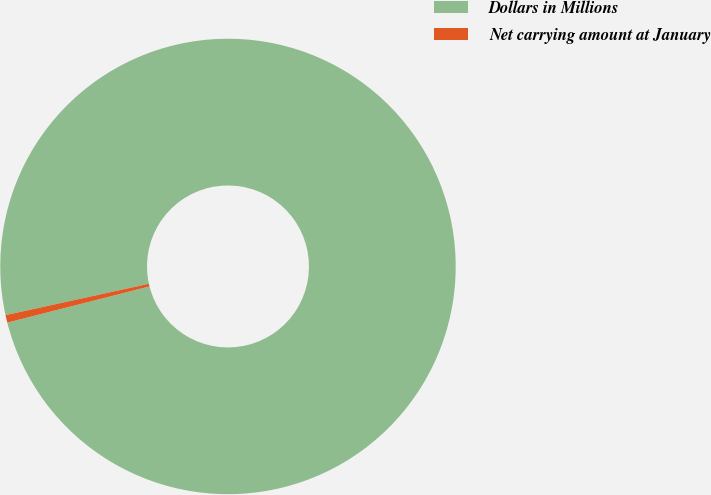Convert chart. <chart><loc_0><loc_0><loc_500><loc_500><pie_chart><fcel>Dollars in Millions<fcel>Net carrying amount at January<nl><fcel>99.46%<fcel>0.54%<nl></chart> 